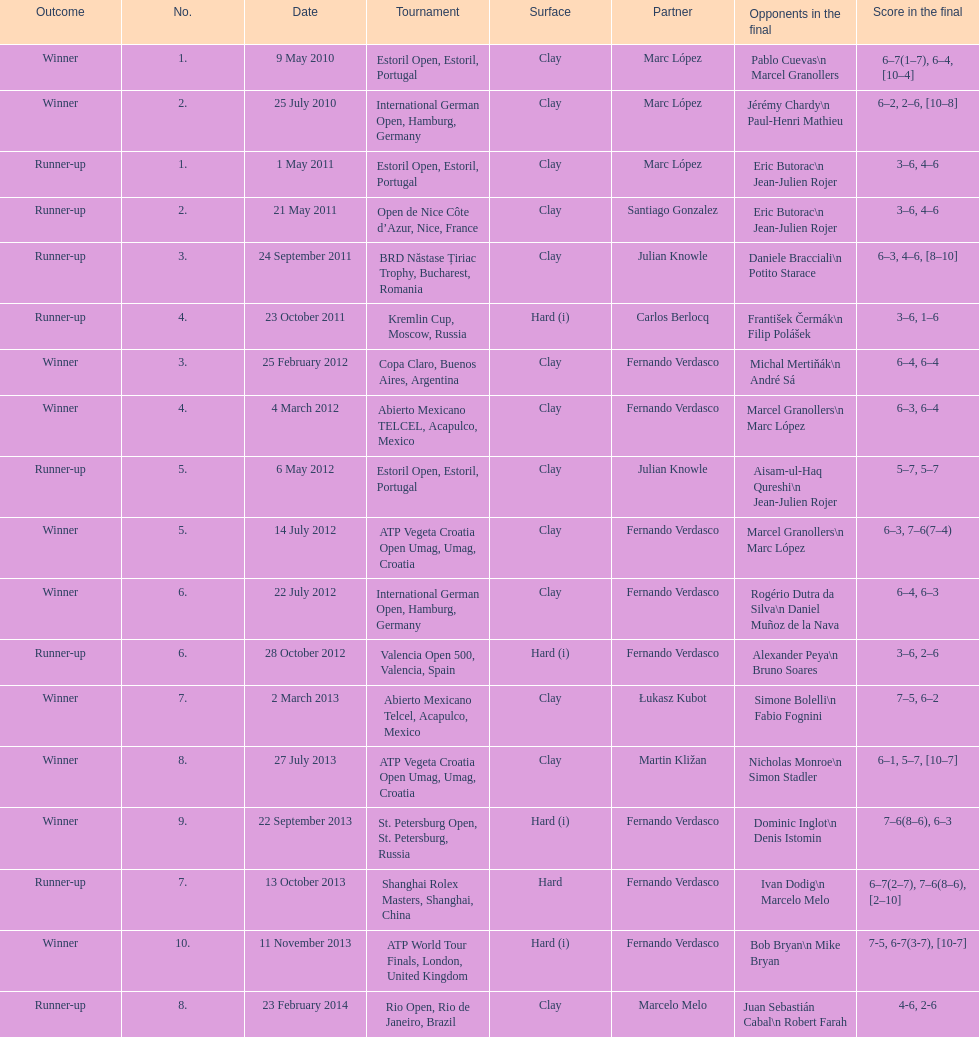Prior to the estoril open, which tournament took place? Abierto Mexicano TELCEL, Acapulco, Mexico. 